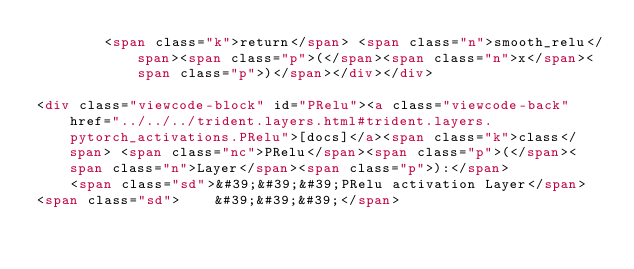Convert code to text. <code><loc_0><loc_0><loc_500><loc_500><_HTML_>        <span class="k">return</span> <span class="n">smooth_relu</span><span class="p">(</span><span class="n">x</span><span class="p">)</span></div></div>

<div class="viewcode-block" id="PRelu"><a class="viewcode-back" href="../../../trident.layers.html#trident.layers.pytorch_activations.PRelu">[docs]</a><span class="k">class</span> <span class="nc">PRelu</span><span class="p">(</span><span class="n">Layer</span><span class="p">):</span>
    <span class="sd">&#39;&#39;&#39;PRelu activation Layer</span>
<span class="sd">    &#39;&#39;&#39;</span></code> 